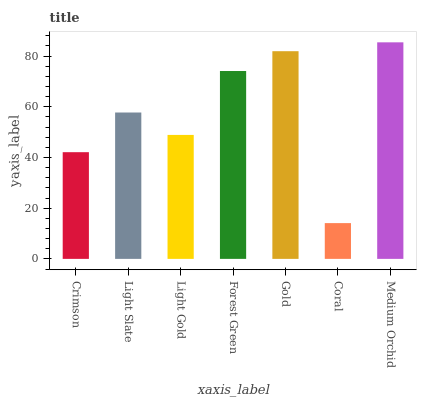Is Coral the minimum?
Answer yes or no. Yes. Is Medium Orchid the maximum?
Answer yes or no. Yes. Is Light Slate the minimum?
Answer yes or no. No. Is Light Slate the maximum?
Answer yes or no. No. Is Light Slate greater than Crimson?
Answer yes or no. Yes. Is Crimson less than Light Slate?
Answer yes or no. Yes. Is Crimson greater than Light Slate?
Answer yes or no. No. Is Light Slate less than Crimson?
Answer yes or no. No. Is Light Slate the high median?
Answer yes or no. Yes. Is Light Slate the low median?
Answer yes or no. Yes. Is Gold the high median?
Answer yes or no. No. Is Forest Green the low median?
Answer yes or no. No. 